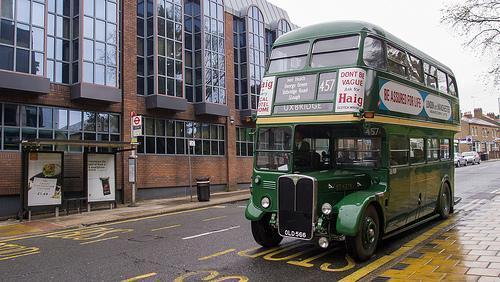How many posters are on the bus stop's partition?
Give a very brief answer. 2. 